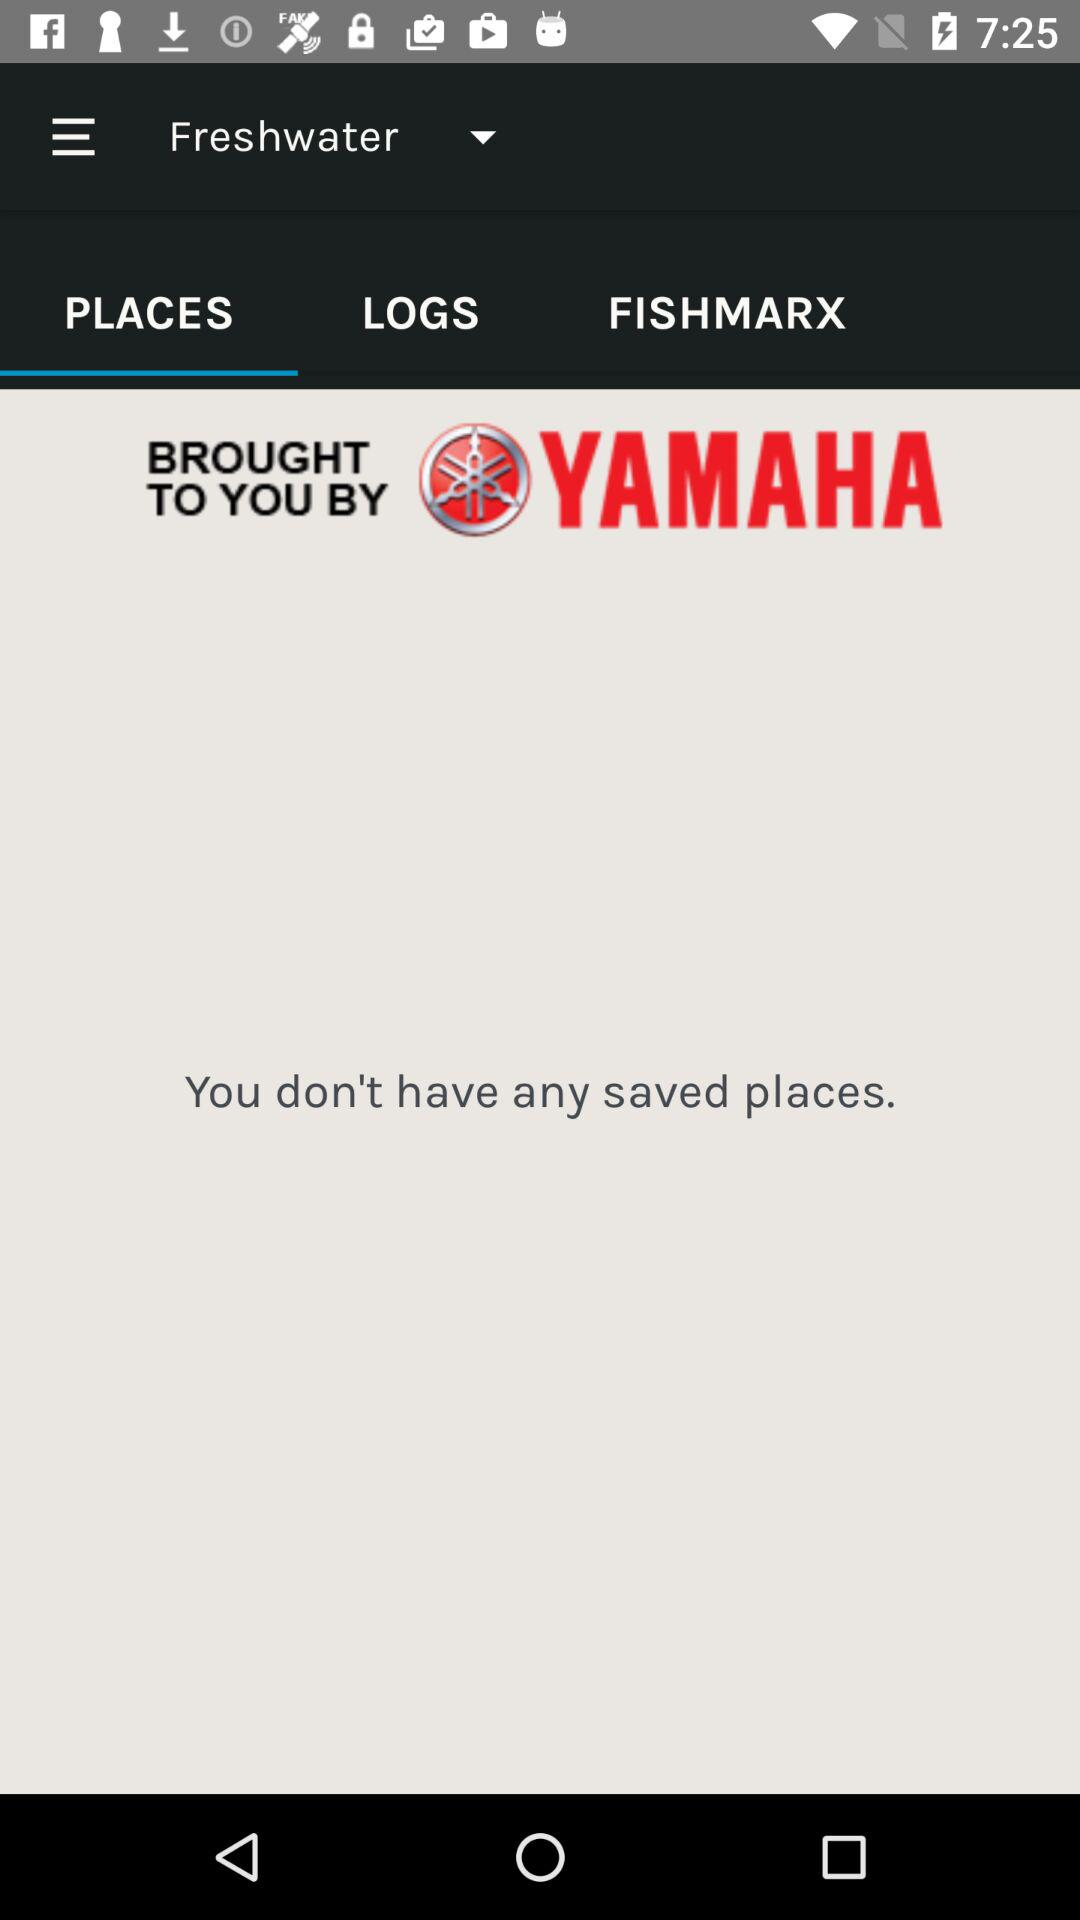Are there any saved places? There are not any saved places. 